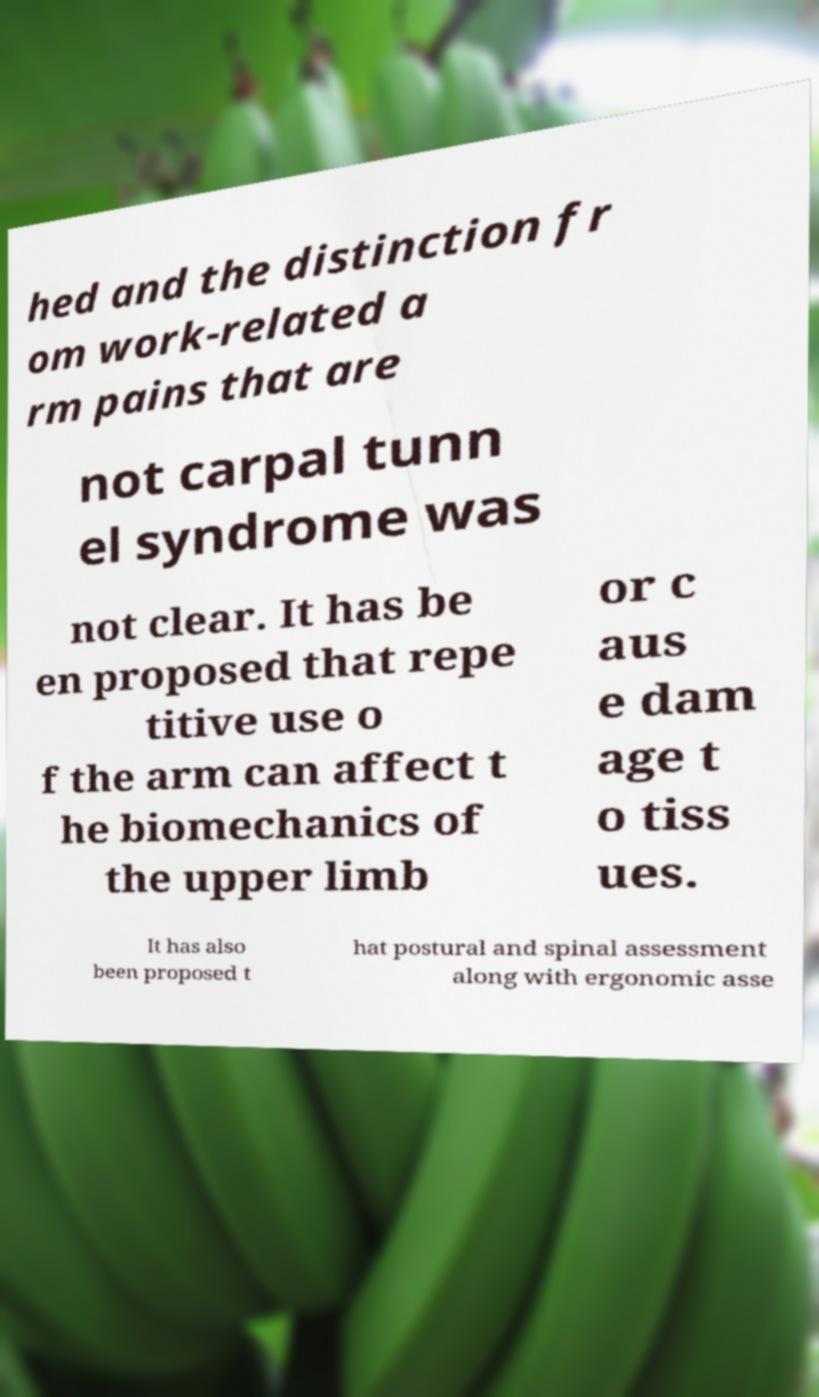Can you accurately transcribe the text from the provided image for me? hed and the distinction fr om work-related a rm pains that are not carpal tunn el syndrome was not clear. It has be en proposed that repe titive use o f the arm can affect t he biomechanics of the upper limb or c aus e dam age t o tiss ues. It has also been proposed t hat postural and spinal assessment along with ergonomic asse 